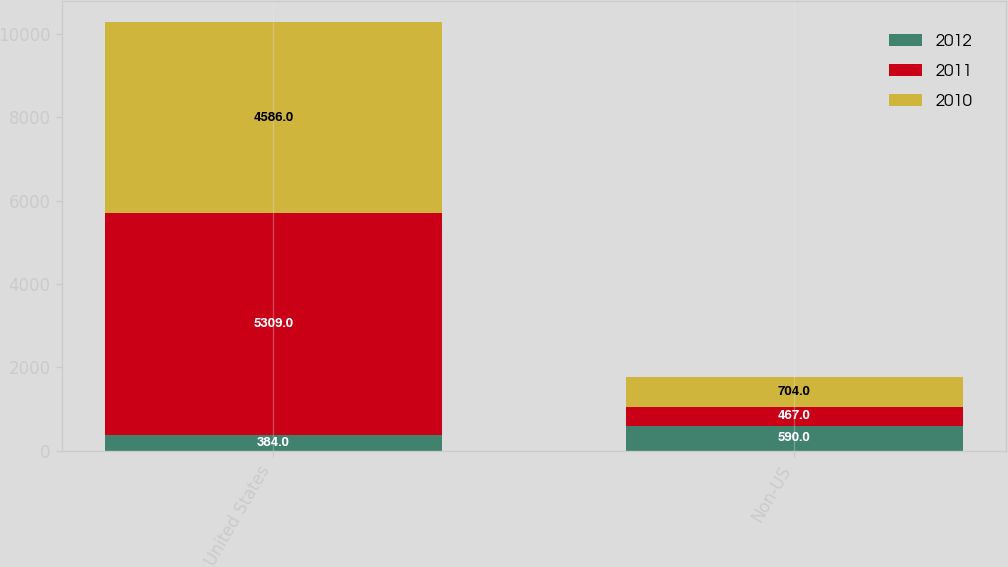Convert chart. <chart><loc_0><loc_0><loc_500><loc_500><stacked_bar_chart><ecel><fcel>United States<fcel>Non-US<nl><fcel>2012<fcel>384<fcel>590<nl><fcel>2011<fcel>5309<fcel>467<nl><fcel>2010<fcel>4586<fcel>704<nl></chart> 